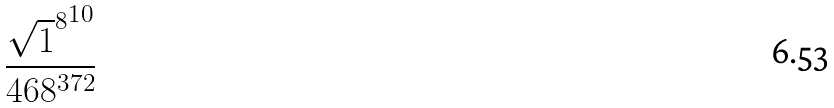Convert formula to latex. <formula><loc_0><loc_0><loc_500><loc_500>\frac { { \sqrt { 1 } ^ { 8 } } ^ { 1 0 } } { 4 6 8 ^ { 3 7 2 } }</formula> 